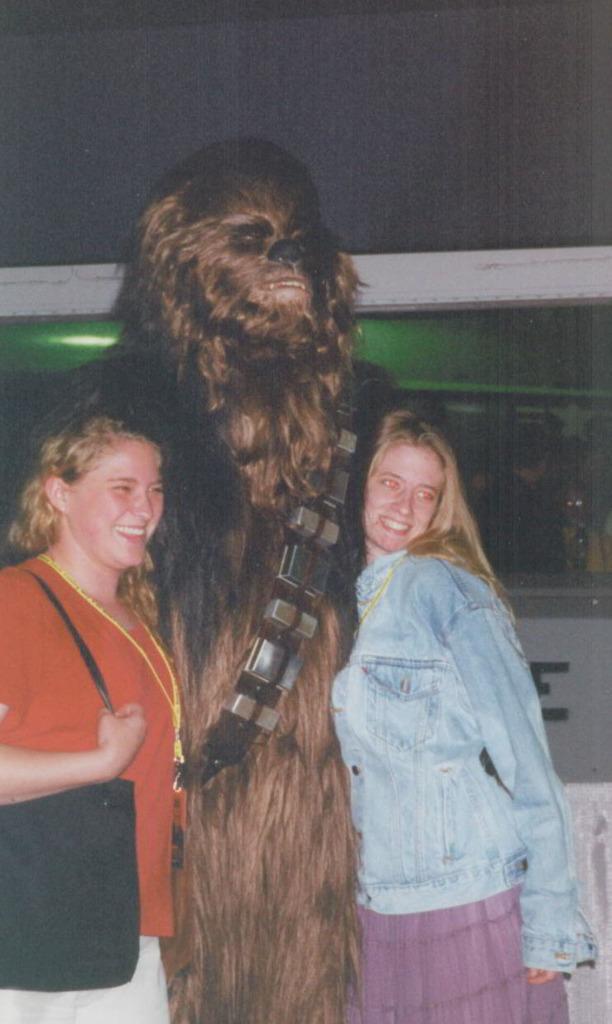Could you give a brief overview of what you see in this image? In the image,there are two women standing beside a person who is wearing an animal costume,both the women are smiling and posing for the photo. 